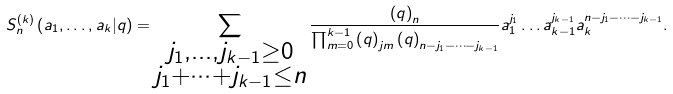Convert formula to latex. <formula><loc_0><loc_0><loc_500><loc_500>S _ { n } ^ { \left ( k \right ) } \left ( a _ { 1 } , \dots , a _ { k } | q \right ) = \sum _ { \substack { j _ { 1 } , \dots , j _ { k - 1 } \geq 0 \\ j _ { 1 } + \dots + j _ { k - 1 } \leq n } } \frac { \left ( q \right ) _ { n } } { \prod _ { m = 0 } ^ { k - 1 } \left ( q \right ) _ { j m } \left ( q \right ) _ { n - j _ { 1 } - \dots - j _ { k - 1 } } } a _ { 1 } ^ { j _ { 1 } } \dots a _ { k - 1 } ^ { j _ { k - 1 } } a _ { k } ^ { n - j _ { 1 } - \dots - j _ { k - 1 } } .</formula> 